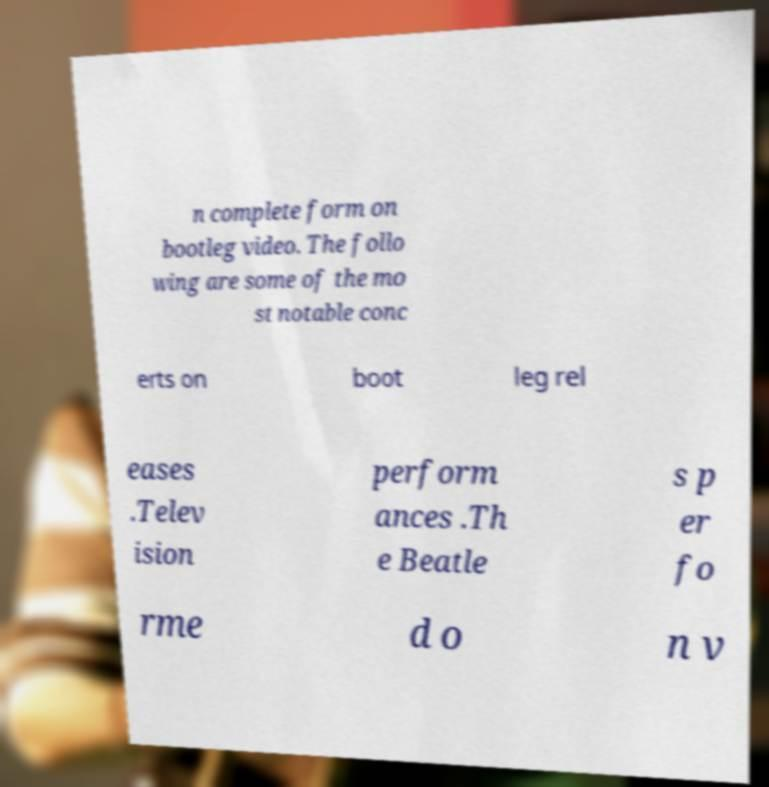I need the written content from this picture converted into text. Can you do that? n complete form on bootleg video. The follo wing are some of the mo st notable conc erts on boot leg rel eases .Telev ision perform ances .Th e Beatle s p er fo rme d o n v 